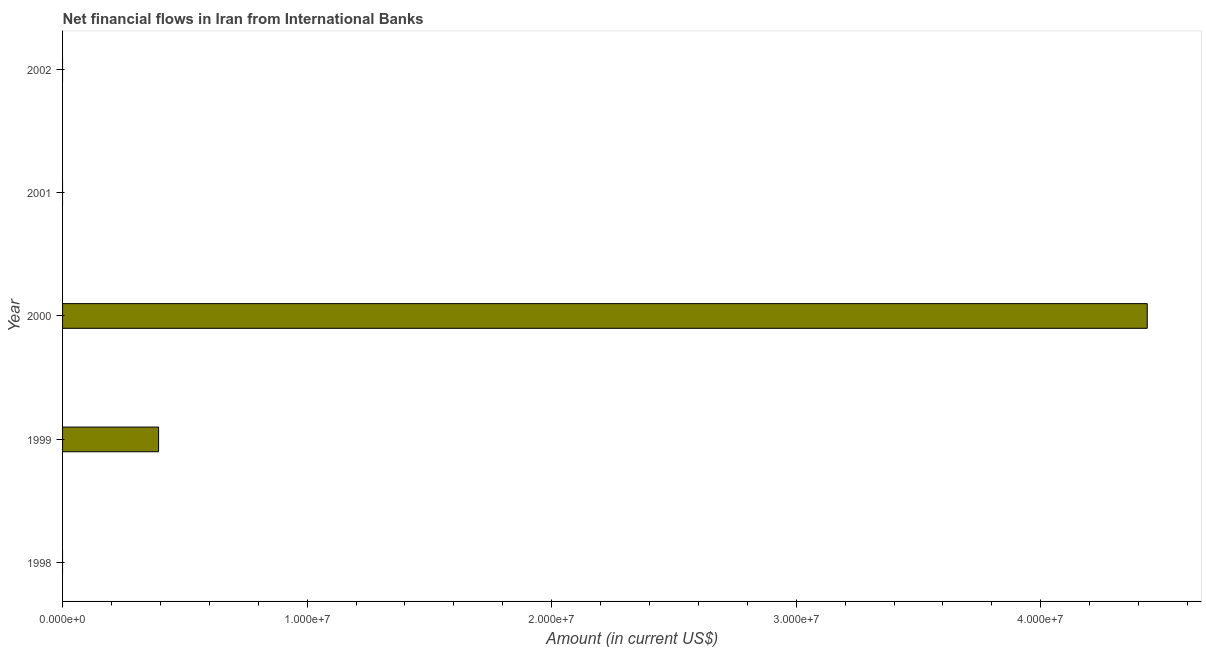What is the title of the graph?
Offer a very short reply. Net financial flows in Iran from International Banks. Across all years, what is the maximum net financial flows from ibrd?
Keep it short and to the point. 4.44e+07. Across all years, what is the minimum net financial flows from ibrd?
Your answer should be compact. 0. In which year was the net financial flows from ibrd maximum?
Your answer should be very brief. 2000. What is the sum of the net financial flows from ibrd?
Offer a terse response. 4.83e+07. What is the difference between the net financial flows from ibrd in 1999 and 2000?
Provide a short and direct response. -4.04e+07. What is the average net financial flows from ibrd per year?
Make the answer very short. 9.66e+06. In how many years, is the net financial flows from ibrd greater than 28000000 US$?
Ensure brevity in your answer.  1. What is the difference between the highest and the lowest net financial flows from ibrd?
Your response must be concise. 4.44e+07. How many years are there in the graph?
Offer a very short reply. 5. What is the difference between two consecutive major ticks on the X-axis?
Offer a terse response. 1.00e+07. What is the Amount (in current US$) in 1999?
Provide a short and direct response. 3.93e+06. What is the Amount (in current US$) in 2000?
Ensure brevity in your answer.  4.44e+07. What is the Amount (in current US$) in 2002?
Your answer should be very brief. 0. What is the difference between the Amount (in current US$) in 1999 and 2000?
Provide a succinct answer. -4.04e+07. What is the ratio of the Amount (in current US$) in 1999 to that in 2000?
Your answer should be very brief. 0.09. 